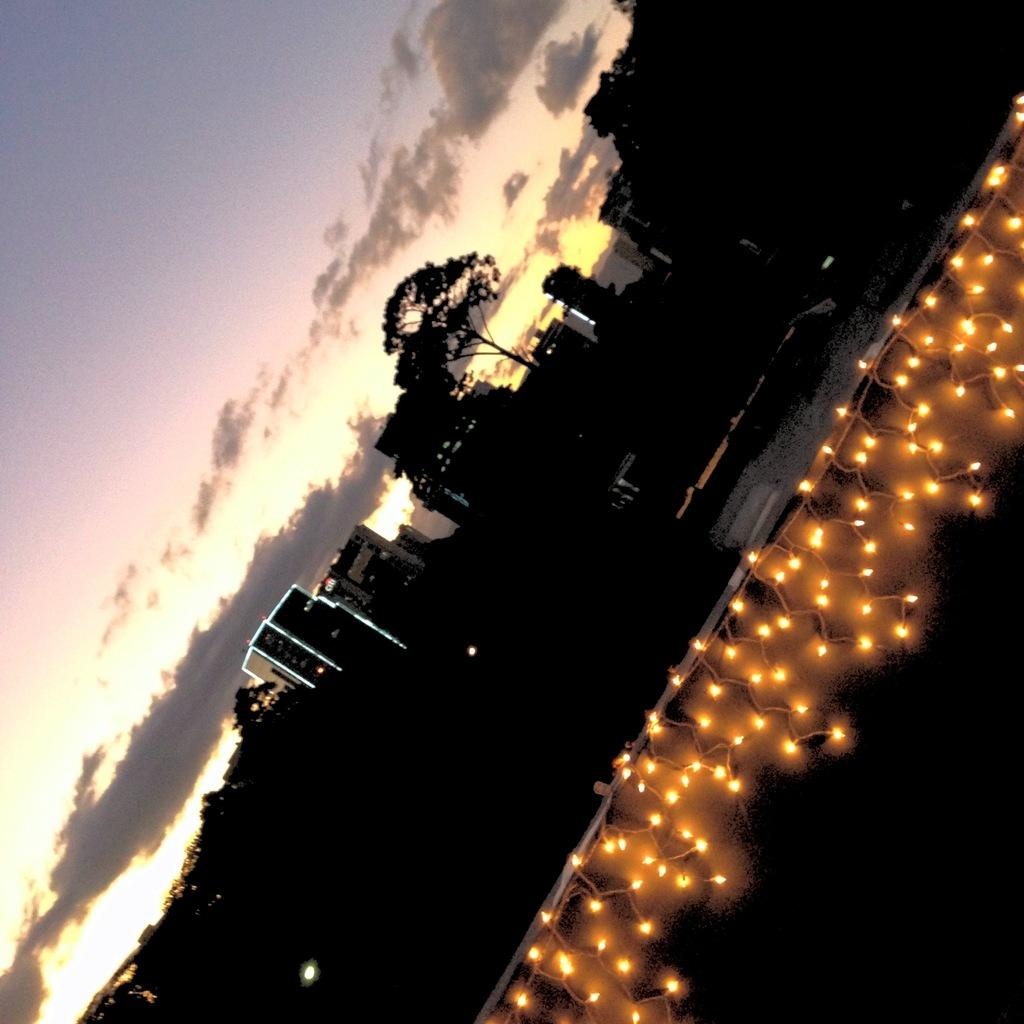What type of structures can be seen in the image? There are buildings in the image. What other natural elements are present in the image? There are trees in the image. What is visible at the top of the image? The sky is visible at the top of the image. What can be seen in the sky? Clouds are present in the sky. Is there any indication of a surface or floor in the image? There might be a floor at the bottom of the image. What type of lighting is present in the foreground of the image? There are lights on the wall in the foreground of the image. How does the goose adjust its feathers in the image? There is no goose present in the image, so it is not possible to answer that question. 